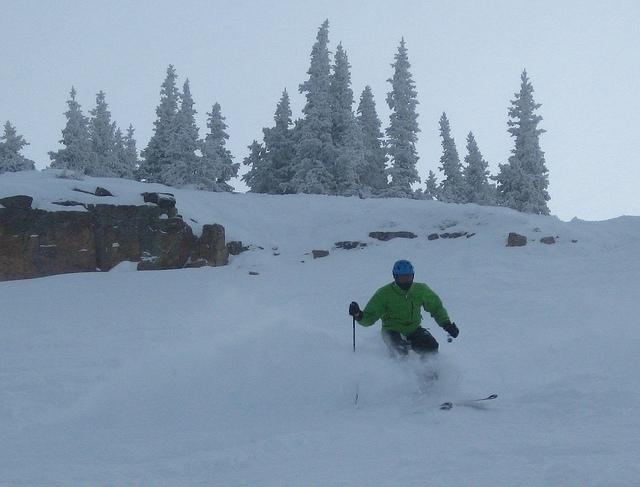Is the guy enjoying what he is doing?
Short answer required. Yes. Is this man skiing?
Answer briefly. Yes. What kind of trees are in the background?
Be succinct. Pine. What is he ,doing?
Quick response, please. Skiing. 